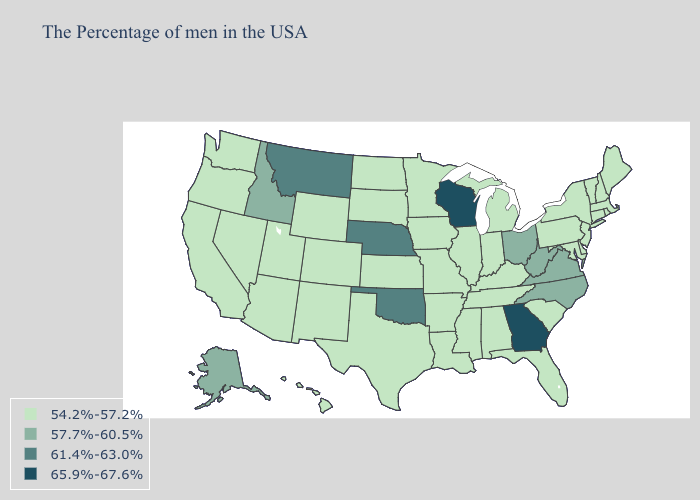Is the legend a continuous bar?
Answer briefly. No. Name the states that have a value in the range 61.4%-63.0%?
Concise answer only. Nebraska, Oklahoma, Montana. Does Oklahoma have the lowest value in the South?
Quick response, please. No. Name the states that have a value in the range 54.2%-57.2%?
Short answer required. Maine, Massachusetts, Rhode Island, New Hampshire, Vermont, Connecticut, New York, New Jersey, Delaware, Maryland, Pennsylvania, South Carolina, Florida, Michigan, Kentucky, Indiana, Alabama, Tennessee, Illinois, Mississippi, Louisiana, Missouri, Arkansas, Minnesota, Iowa, Kansas, Texas, South Dakota, North Dakota, Wyoming, Colorado, New Mexico, Utah, Arizona, Nevada, California, Washington, Oregon, Hawaii. Does Maryland have a higher value than Kansas?
Give a very brief answer. No. What is the value of North Carolina?
Concise answer only. 57.7%-60.5%. Among the states that border Kansas , which have the highest value?
Quick response, please. Nebraska, Oklahoma. Among the states that border Arizona , which have the lowest value?
Keep it brief. Colorado, New Mexico, Utah, Nevada, California. What is the value of California?
Answer briefly. 54.2%-57.2%. Which states have the lowest value in the West?
Answer briefly. Wyoming, Colorado, New Mexico, Utah, Arizona, Nevada, California, Washington, Oregon, Hawaii. Does Montana have the highest value in the West?
Write a very short answer. Yes. What is the lowest value in the South?
Be succinct. 54.2%-57.2%. What is the lowest value in states that border Rhode Island?
Concise answer only. 54.2%-57.2%. Name the states that have a value in the range 57.7%-60.5%?
Answer briefly. Virginia, North Carolina, West Virginia, Ohio, Idaho, Alaska. Does the map have missing data?
Quick response, please. No. 